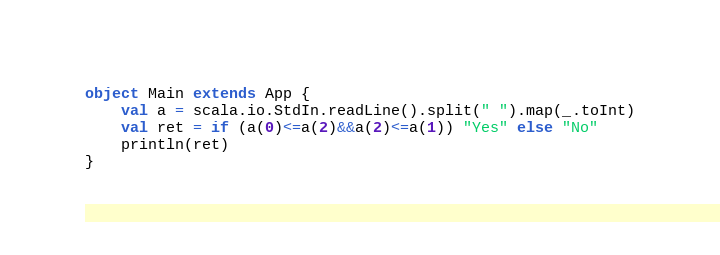<code> <loc_0><loc_0><loc_500><loc_500><_Scala_>object Main extends App {
    val a = scala.io.StdIn.readLine().split(" ").map(_.toInt)
    val ret = if (a(0)<=a(2)&&a(2)<=a(1)) "Yes" else "No"
    println(ret)
}
</code> 